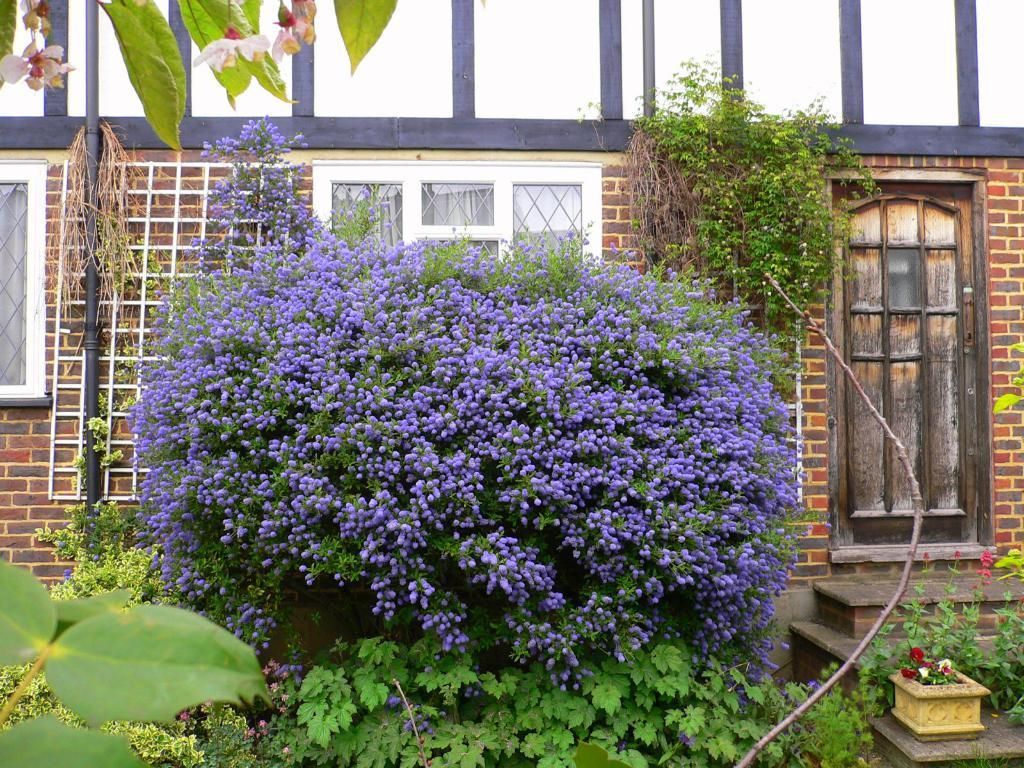What types of plants and flowers can be seen in the foreground of the image? There are plants and flowers in the foreground of the image. What can be seen at the top of the image? Leaves and flowers are visible at the top of the image. What is located in the middle of the image? There is a building in the middle of the image, along with a pipe and windows. What type of boot is being used to water the plants in the image? There is no boot present in the image, and the plants do not appear to be watered. 